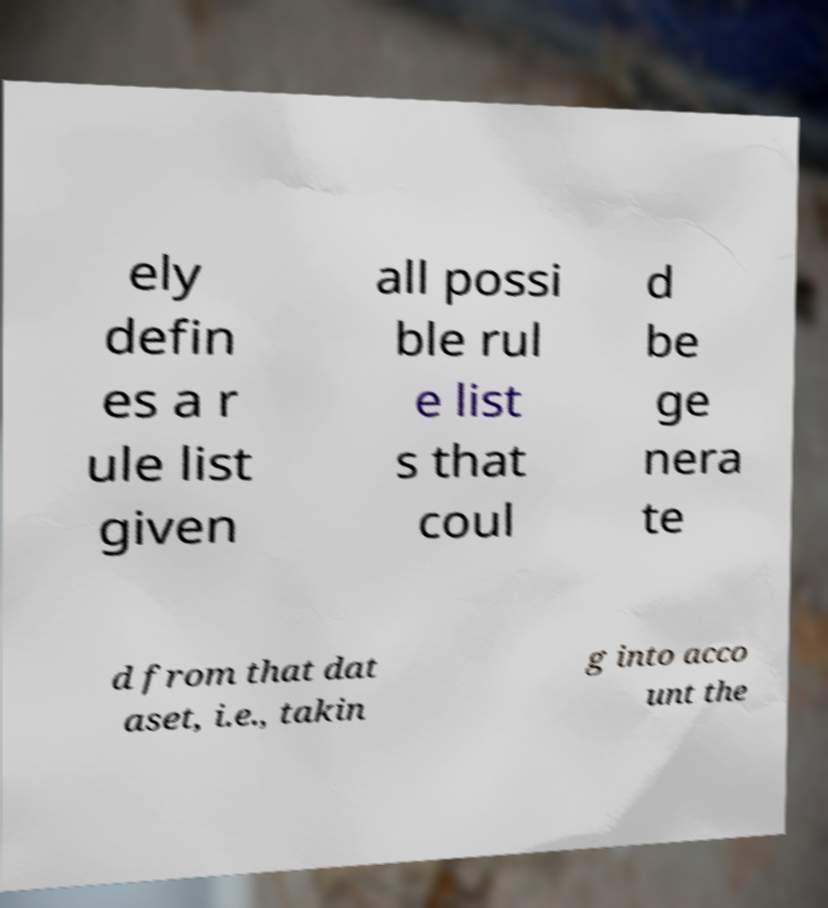Could you extract and type out the text from this image? ely defin es a r ule list given all possi ble rul e list s that coul d be ge nera te d from that dat aset, i.e., takin g into acco unt the 